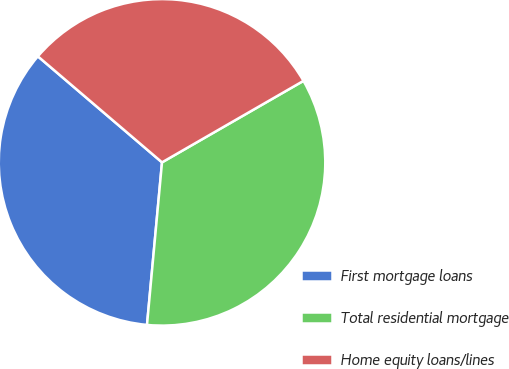<chart> <loc_0><loc_0><loc_500><loc_500><pie_chart><fcel>First mortgage loans<fcel>Total residential mortgage<fcel>Home equity loans/lines<nl><fcel>34.78%<fcel>34.78%<fcel>30.43%<nl></chart> 